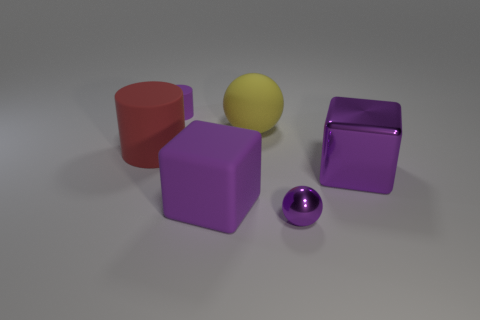Subtract 1 blocks. How many blocks are left? 1 Subtract all cylinders. How many objects are left? 4 Subtract all big green metal objects. Subtract all big yellow rubber spheres. How many objects are left? 5 Add 5 red matte cylinders. How many red matte cylinders are left? 6 Add 4 purple things. How many purple things exist? 8 Add 4 red objects. How many objects exist? 10 Subtract all yellow balls. How many balls are left? 1 Subtract 0 blue blocks. How many objects are left? 6 Subtract all purple balls. Subtract all red cylinders. How many balls are left? 1 Subtract all blue cubes. How many purple balls are left? 1 